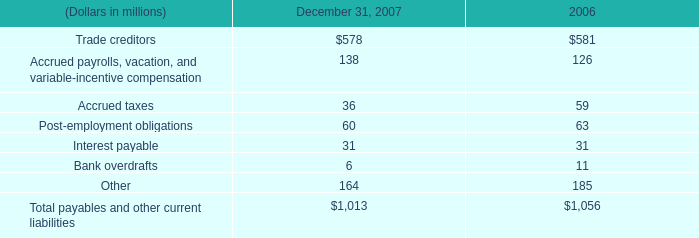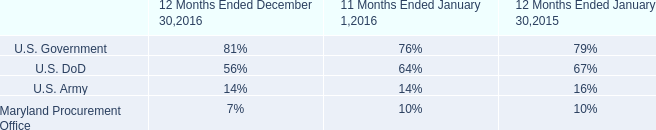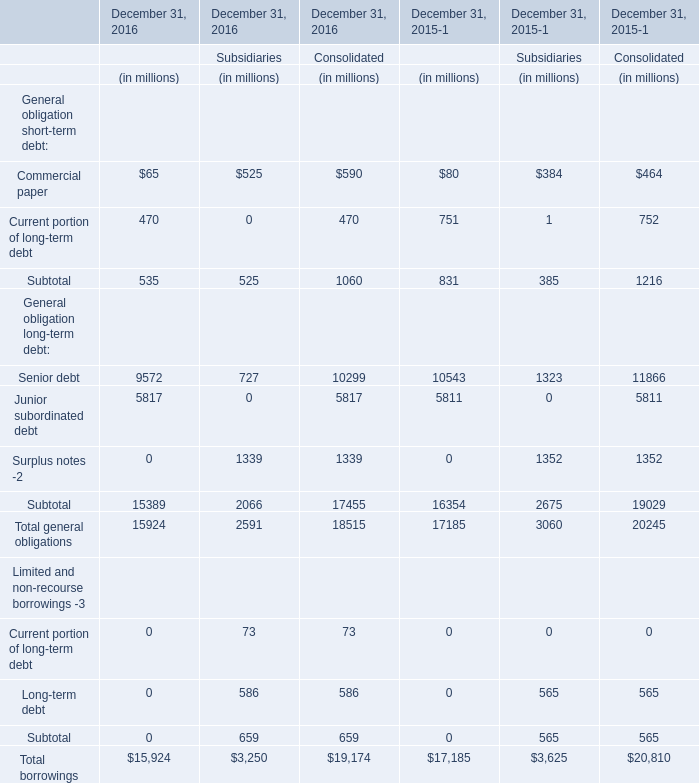Which year is the General obligation long-term debt statement:Senior debt in terems of Consolidated smaller than 11000 million ? 
Answer: 2016. 